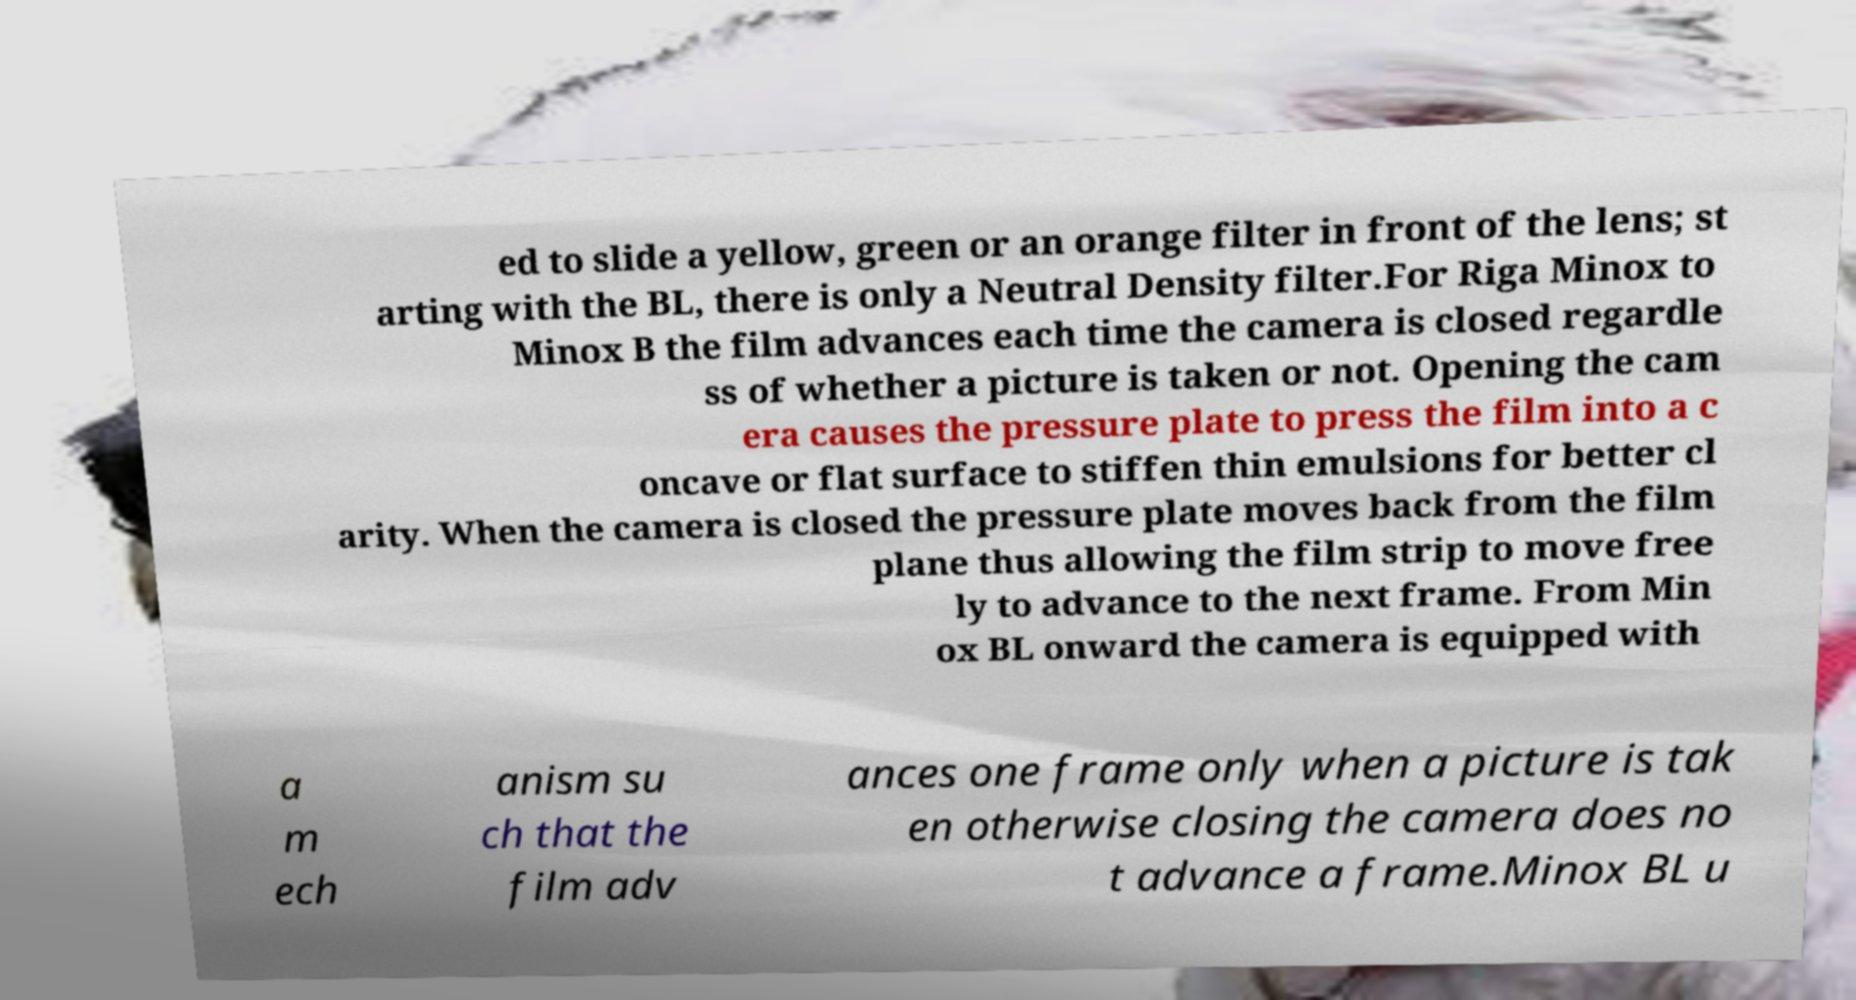For documentation purposes, I need the text within this image transcribed. Could you provide that? ed to slide a yellow, green or an orange filter in front of the lens; st arting with the BL, there is only a Neutral Density filter.For Riga Minox to Minox B the film advances each time the camera is closed regardle ss of whether a picture is taken or not. Opening the cam era causes the pressure plate to press the film into a c oncave or flat surface to stiffen thin emulsions for better cl arity. When the camera is closed the pressure plate moves back from the film plane thus allowing the film strip to move free ly to advance to the next frame. From Min ox BL onward the camera is equipped with a m ech anism su ch that the film adv ances one frame only when a picture is tak en otherwise closing the camera does no t advance a frame.Minox BL u 